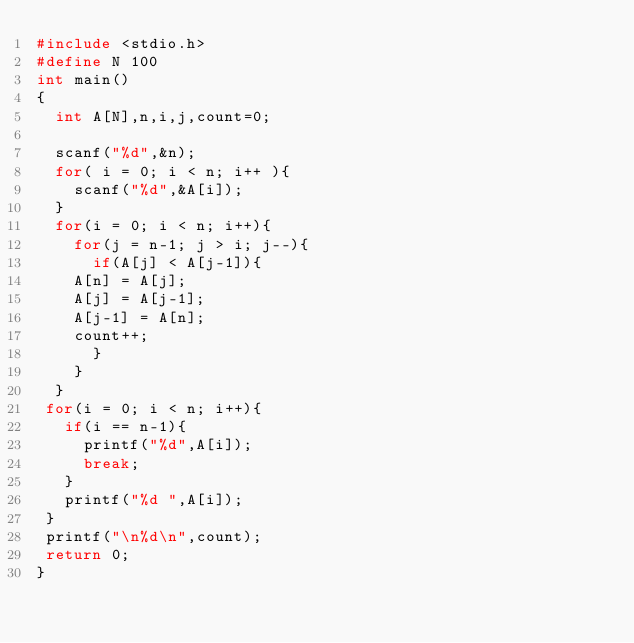Convert code to text. <code><loc_0><loc_0><loc_500><loc_500><_C_>#include <stdio.h>
#define N 100
int main()
{
  int A[N],n,i,j,count=0;

  scanf("%d",&n);
  for( i = 0; i < n; i++ ){
    scanf("%d",&A[i]);
  }
  for(i = 0; i < n; i++){
    for(j = n-1; j > i; j--){
      if(A[j] < A[j-1]){
	A[n] = A[j];
	A[j] = A[j-1];
	A[j-1] = A[n];
	count++;
      }
    }
  }
 for(i = 0; i < n; i++){
   if(i == n-1){
     printf("%d",A[i]);
     break;
   }
   printf("%d ",A[i]);
 }
 printf("\n%d\n",count);
 return 0;
}</code> 